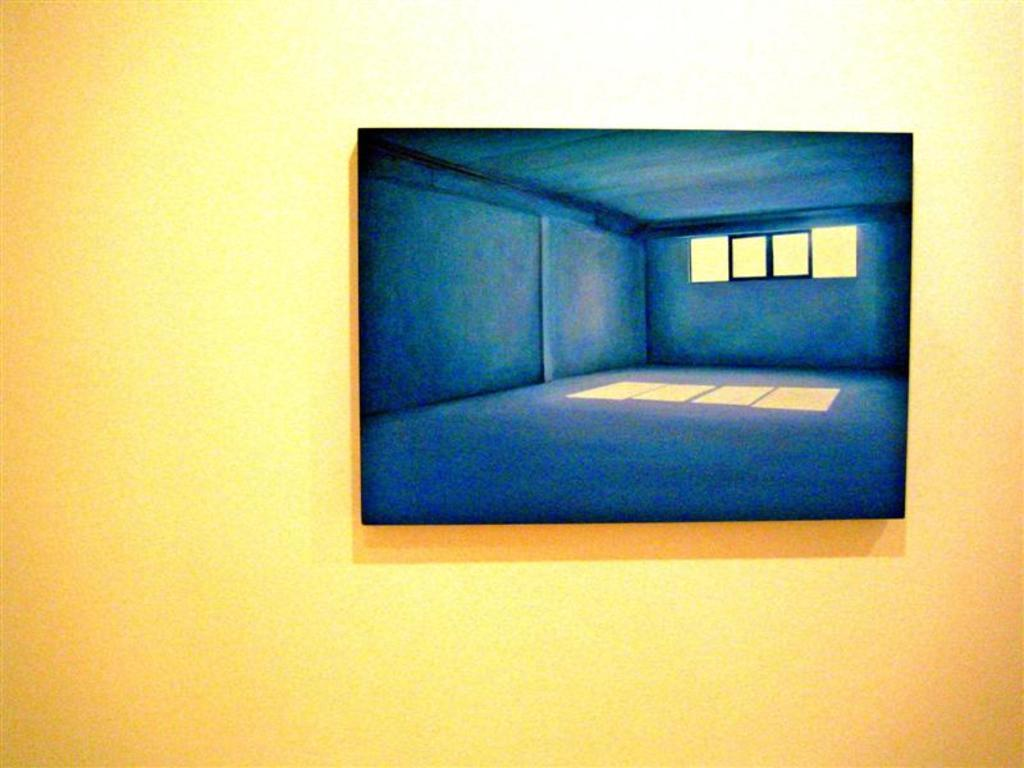What is hanging on the wall in the image? There is a picture frame on the wall. What is inside the picture frame? The picture frame contains a painting. What elements can be seen in the painting? The painting depicts walls and windows. Can you see any rabbits playing on the playground in the image? There is no playground or rabbit present in the image; the painting depicts walls and windows. 